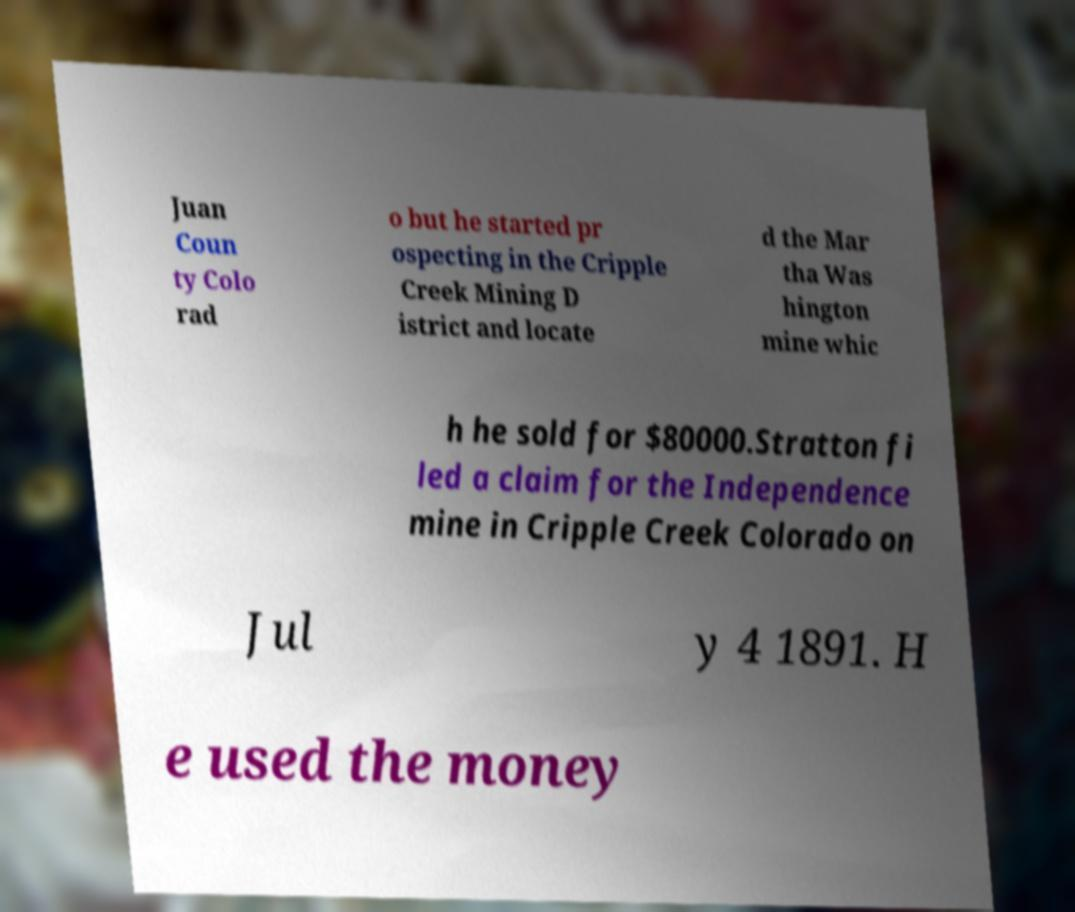For documentation purposes, I need the text within this image transcribed. Could you provide that? Juan Coun ty Colo rad o but he started pr ospecting in the Cripple Creek Mining D istrict and locate d the Mar tha Was hington mine whic h he sold for $80000.Stratton fi led a claim for the Independence mine in Cripple Creek Colorado on Jul y 4 1891. H e used the money 